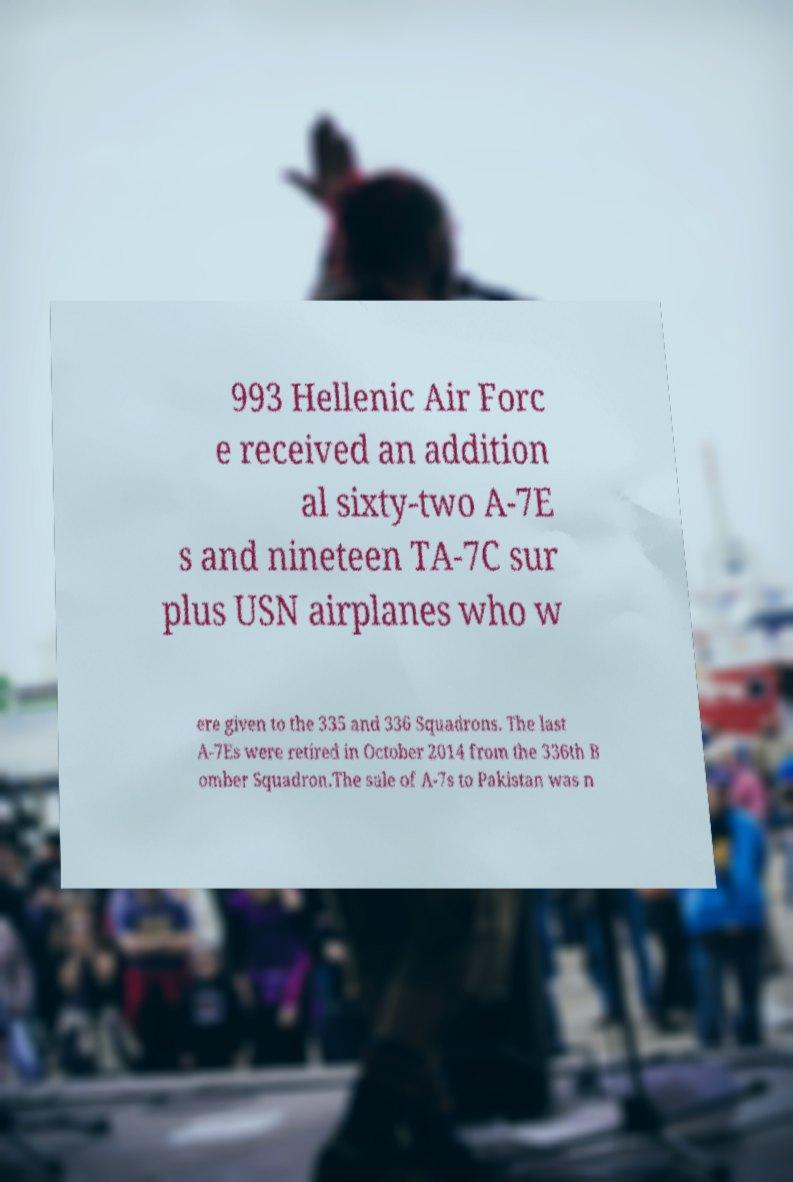Can you read and provide the text displayed in the image?This photo seems to have some interesting text. Can you extract and type it out for me? 993 Hellenic Air Forc e received an addition al sixty-two A-7E s and nineteen TA-7C sur plus USN airplanes who w ere given to the 335 and 336 Squadrons. The last A-7Es were retired in October 2014 from the 336th B omber Squadron.The sale of A-7s to Pakistan was n 